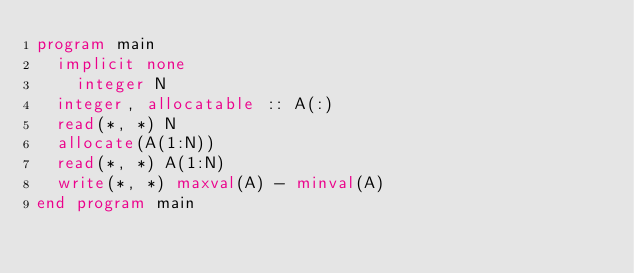Convert code to text. <code><loc_0><loc_0><loc_500><loc_500><_FORTRAN_>program main
	implicit none
    integer N
	integer, allocatable :: A(:)
	read(*, *) N
	allocate(A(1:N))
	read(*, *) A(1:N)
	write(*, *) maxval(A) - minval(A)
end program main</code> 